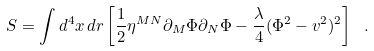<formula> <loc_0><loc_0><loc_500><loc_500>S = \int d ^ { 4 } x \, d r \left [ \frac { 1 } { 2 } \eta ^ { M N } \partial _ { M } \Phi \partial _ { N } \Phi - \frac { \lambda } { 4 } ( \Phi ^ { 2 } - v ^ { 2 } ) ^ { 2 } \right ] \ .</formula> 